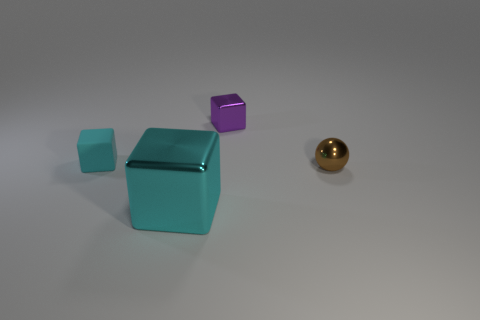Subtract 1 blocks. How many blocks are left? 2 Add 4 brown rubber spheres. How many objects exist? 8 Subtract all balls. How many objects are left? 3 Add 1 brown metal things. How many brown metal things exist? 2 Subtract 0 purple cylinders. How many objects are left? 4 Subtract all big purple shiny things. Subtract all big cyan metallic blocks. How many objects are left? 3 Add 3 shiny spheres. How many shiny spheres are left? 4 